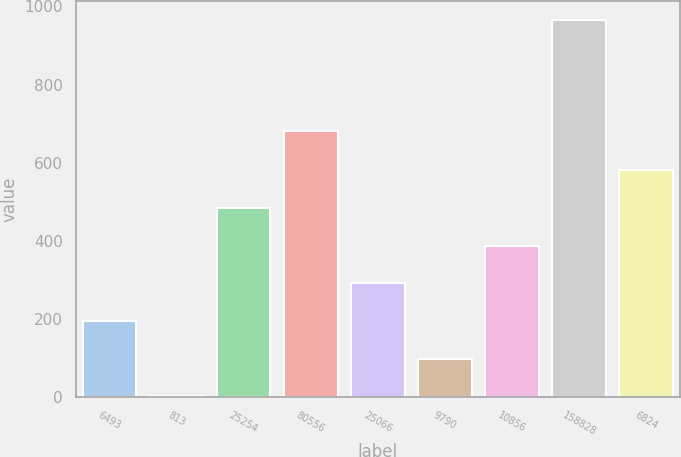Convert chart. <chart><loc_0><loc_0><loc_500><loc_500><bar_chart><fcel>6493<fcel>813<fcel>25254<fcel>80556<fcel>25066<fcel>9790<fcel>10856<fcel>158828<fcel>6824<nl><fcel>194.8<fcel>2<fcel>484<fcel>680<fcel>291.2<fcel>98.4<fcel>387.6<fcel>966<fcel>580.4<nl></chart> 